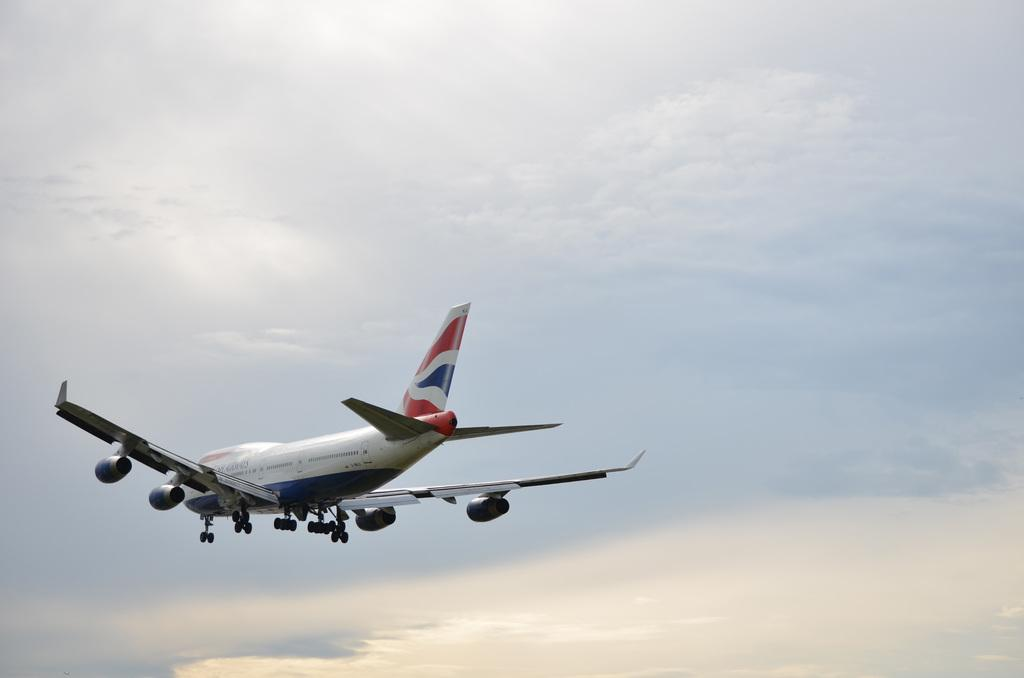What is the main subject of the image? The main subject of the image is an aircraft. Can you describe the position of the aircraft in the image? The aircraft is in the air in the image. What else can be seen in the image besides the aircraft? The sky is visible in the image. What type of cork can be seen in the image? There is no cork present in the image. What relation does the aircraft have with the operation in the image? The image does not depict any operation, and the aircraft is the only subject present. 